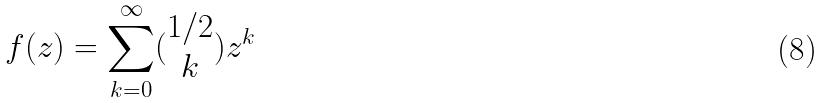<formula> <loc_0><loc_0><loc_500><loc_500>f ( z ) = \sum _ { k = 0 } ^ { \infty } ( \begin{matrix} 1 / 2 \\ k \end{matrix} ) z ^ { k }</formula> 